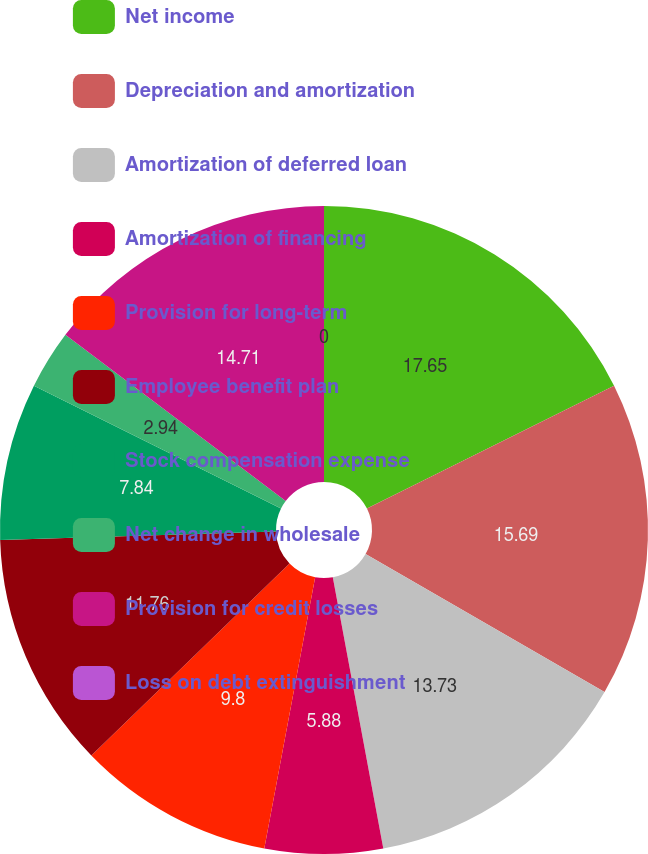Convert chart to OTSL. <chart><loc_0><loc_0><loc_500><loc_500><pie_chart><fcel>Net income<fcel>Depreciation and amortization<fcel>Amortization of deferred loan<fcel>Amortization of financing<fcel>Provision for long-term<fcel>Employee benefit plan<fcel>Stock compensation expense<fcel>Net change in wholesale<fcel>Provision for credit losses<fcel>Loss on debt extinguishment<nl><fcel>17.65%<fcel>15.69%<fcel>13.73%<fcel>5.88%<fcel>9.8%<fcel>11.76%<fcel>7.84%<fcel>2.94%<fcel>14.71%<fcel>0.0%<nl></chart> 